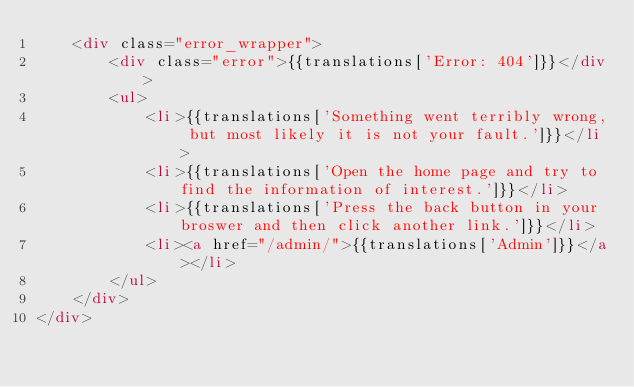<code> <loc_0><loc_0><loc_500><loc_500><_HTML_>    <div class="error_wrapper">
        <div class="error">{{translations['Error: 404']}}</div>
        <ul>
            <li>{{translations['Something went terribly wrong, but most likely it is not your fault.']}}</li>
            <li>{{translations['Open the home page and try to find the information of interest.']}}</li>
            <li>{{translations['Press the back button in your broswer and then click another link.']}}</li>
            <li><a href="/admin/">{{translations['Admin']}}</a></li>
        </ul>
    </div>
</div>
</code> 